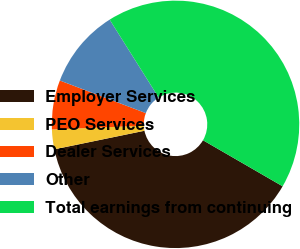Convert chart. <chart><loc_0><loc_0><loc_500><loc_500><pie_chart><fcel>Employer Services<fcel>PEO Services<fcel>Dealer Services<fcel>Other<fcel>Total earnings from continuing<nl><fcel>38.42%<fcel>2.57%<fcel>6.43%<fcel>10.3%<fcel>42.28%<nl></chart> 